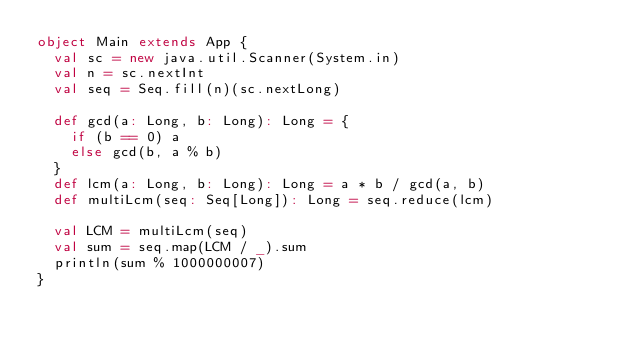Convert code to text. <code><loc_0><loc_0><loc_500><loc_500><_Scala_>object Main extends App {
  val sc = new java.util.Scanner(System.in)
  val n = sc.nextInt
  val seq = Seq.fill(n)(sc.nextLong)
  
  def gcd(a: Long, b: Long): Long = {
    if (b == 0) a
    else gcd(b, a % b)
  }
  def lcm(a: Long, b: Long): Long = a * b / gcd(a, b)
  def multiLcm(seq: Seq[Long]): Long = seq.reduce(lcm)
  
  val LCM = multiLcm(seq)
  val sum = seq.map(LCM / _).sum
  println(sum % 1000000007)
}</code> 